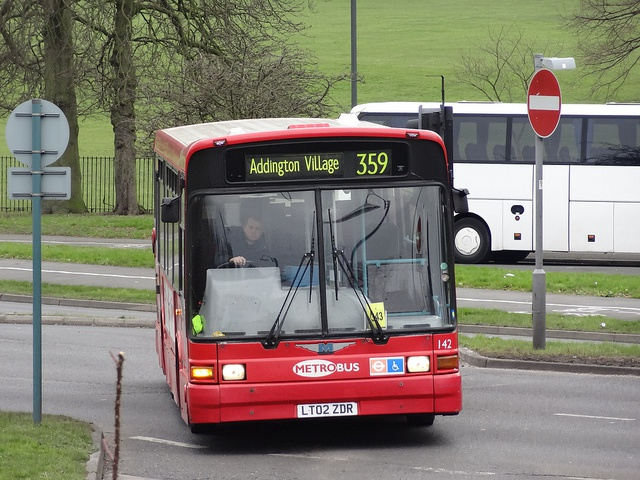Describe the objects in this image and their specific colors. I can see bus in olive, black, gray, darkgray, and brown tones, bus in olive, white, gray, and black tones, and people in olive, gray, black, and darkgray tones in this image. 